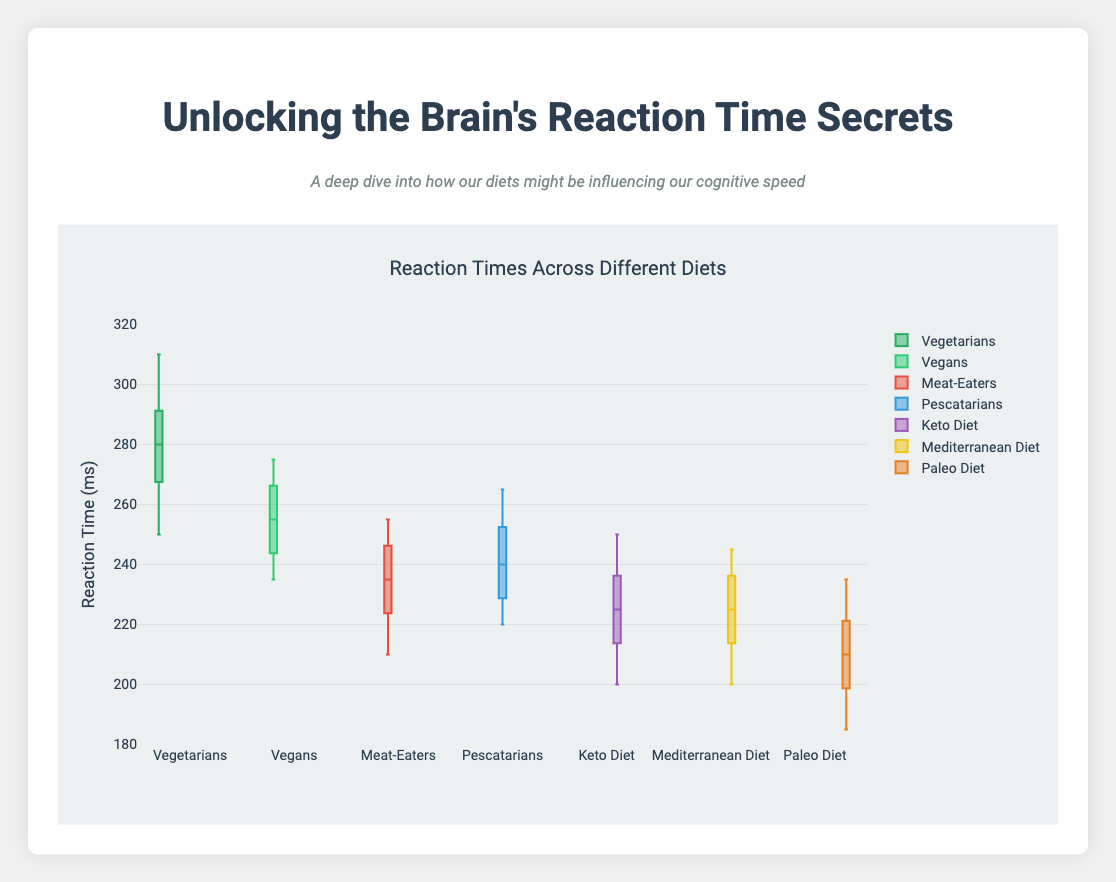What’s the title of the figure? The figure’s title is generally found at the top, summarizing the content in brief. Here, it is “Reaction Times Across Different Diets.”
Answer: Reaction Times Across Different Diets What is the range of reaction times displayed in the figure? From the visual range on the y-axis, the minimum is a little below 200 ms, and the maximum is around 320 ms.
Answer: 180-320 ms Which group has the lowest median reaction time? Observing the median lines within the boxes, the Paleo Diet group shows the lowest median reaction time, around 210 ms.
Answer: Paleo Diet Which group has the highest median reaction time? Looking again at the median lines, the Vegetarians group shows the highest median reaction time, around 280 ms.
Answer: Vegetarians How many dietary groups are displayed in the box plot? Count the number of box plots present, each representing a different dietary group. Here, there are 7 in total.
Answer: 7 Which dietary habit has the widest interquartile range (IQR)? The box part of the plot represents the IQR. The Vegetarians group has the widest box.
Answer: Vegetarians Which dietary group appears to have the most consistent reaction times? The group with the smallest IQR indicates less variability. The Paleo Diet has the smallest IQR, suggesting more consistency.
Answer: Paleo Diet What is the approximate median reaction time for Meat-Eaters? The line inside the Meat-Eaters’ box is the median, approximately at 235 ms.
Answer: 235 ms Which diets have the top whisker (maximum value) extending to 265 ms or above? The whiskers mark outliers or the range. Pescatarians and Vegans have top whiskers reaching or extending past 265 ms.
Answer: Pescatarians, Vegans Compare the reaction times of the Keto Diet with the Mediterranean Diet. Which tends to have faster reaction times? By comparing medians, the Keto Diet's median is around 220 ms, while Mediterranean is around 225 ms, making Keto slightly faster on average.
Answer: Keto Diet 